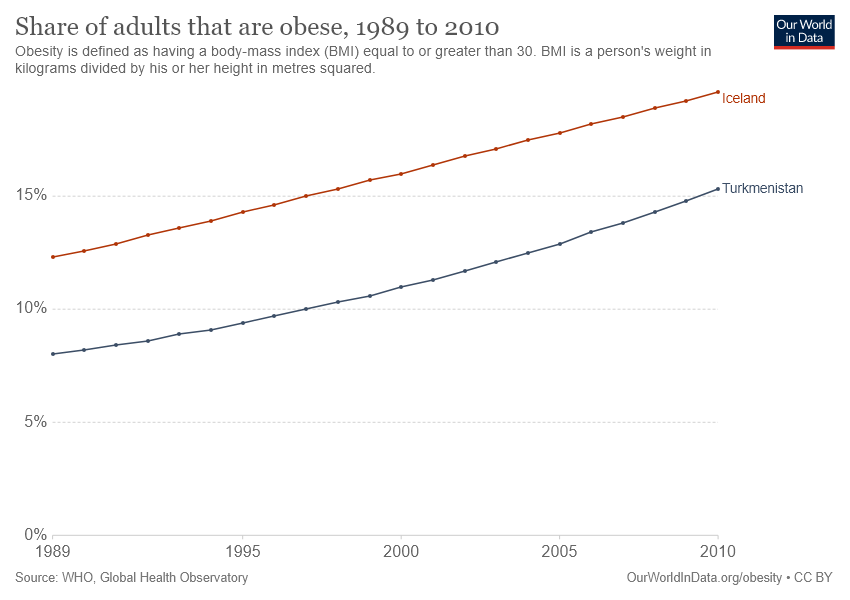Specify some key components in this picture. In 2010, the share of obese individuals was at its highest in Iceland. In Turkmenistan, the share of obese individuals has been increasing year after year, and as of 2021, it is estimated that over 10% of the population is obese. This trend is a cause for concern and requires immediate action to address the underlying factors contributing to the rise in obesity rates. 